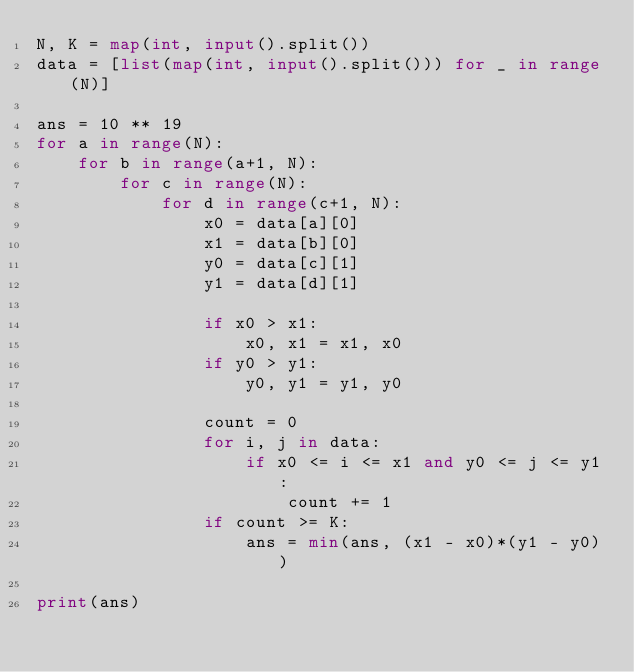<code> <loc_0><loc_0><loc_500><loc_500><_Python_>N, K = map(int, input().split())
data = [list(map(int, input().split())) for _ in range(N)]

ans = 10 ** 19
for a in range(N):
    for b in range(a+1, N):
        for c in range(N):
            for d in range(c+1, N):
                x0 = data[a][0]
                x1 = data[b][0]
                y0 = data[c][1]
                y1 = data[d][1]

                if x0 > x1:
                    x0, x1 = x1, x0
                if y0 > y1:
                    y0, y1 = y1, y0

                count = 0
                for i, j in data:
                    if x0 <= i <= x1 and y0 <= j <= y1:
                        count += 1
                if count >= K:
                    ans = min(ans, (x1 - x0)*(y1 - y0))

print(ans)</code> 